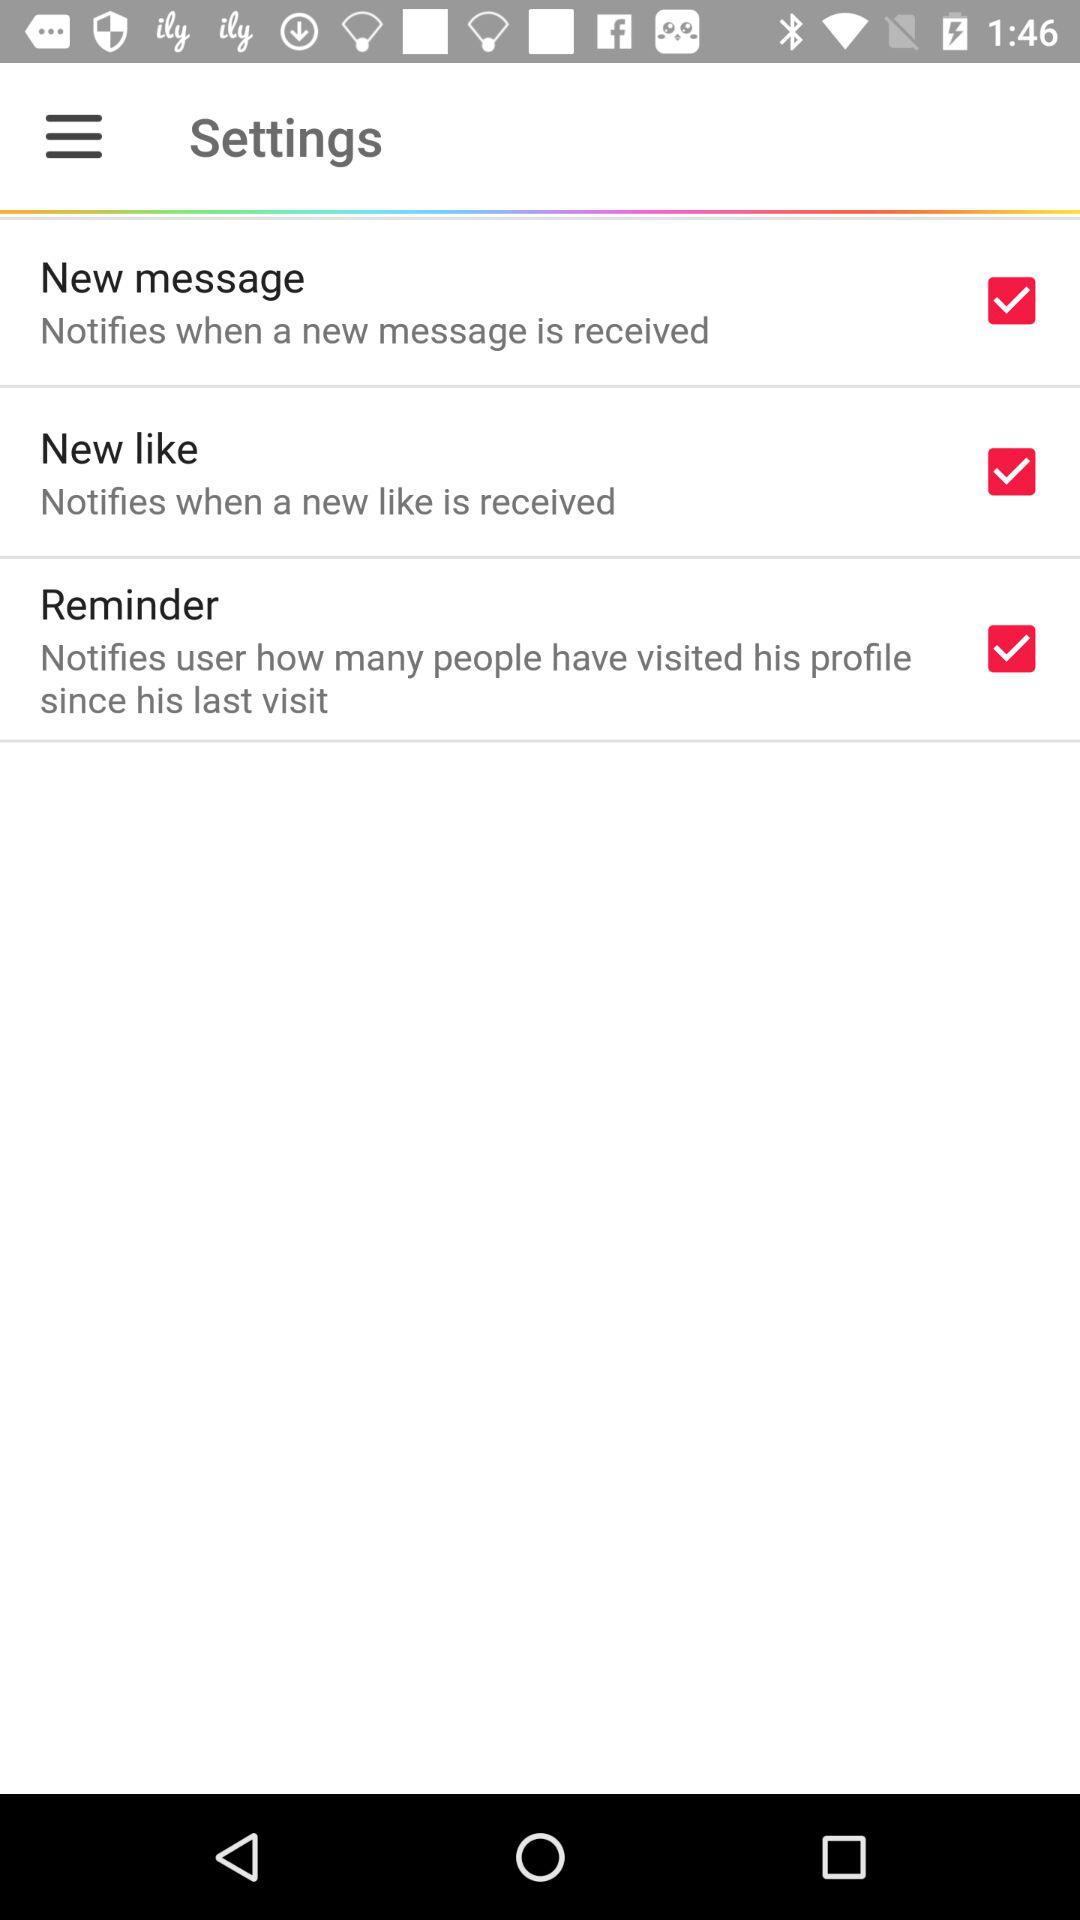What is the current state of "Reminder"? The current state of "Reminder" is "on". 